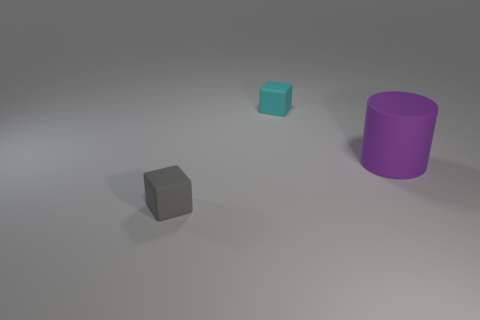Add 2 big rubber cylinders. How many objects exist? 5 Subtract all cubes. How many objects are left? 1 Add 2 cylinders. How many cylinders are left? 3 Add 2 purple cylinders. How many purple cylinders exist? 3 Subtract 0 brown cylinders. How many objects are left? 3 Subtract all large red matte balls. Subtract all tiny cyan rubber cubes. How many objects are left? 2 